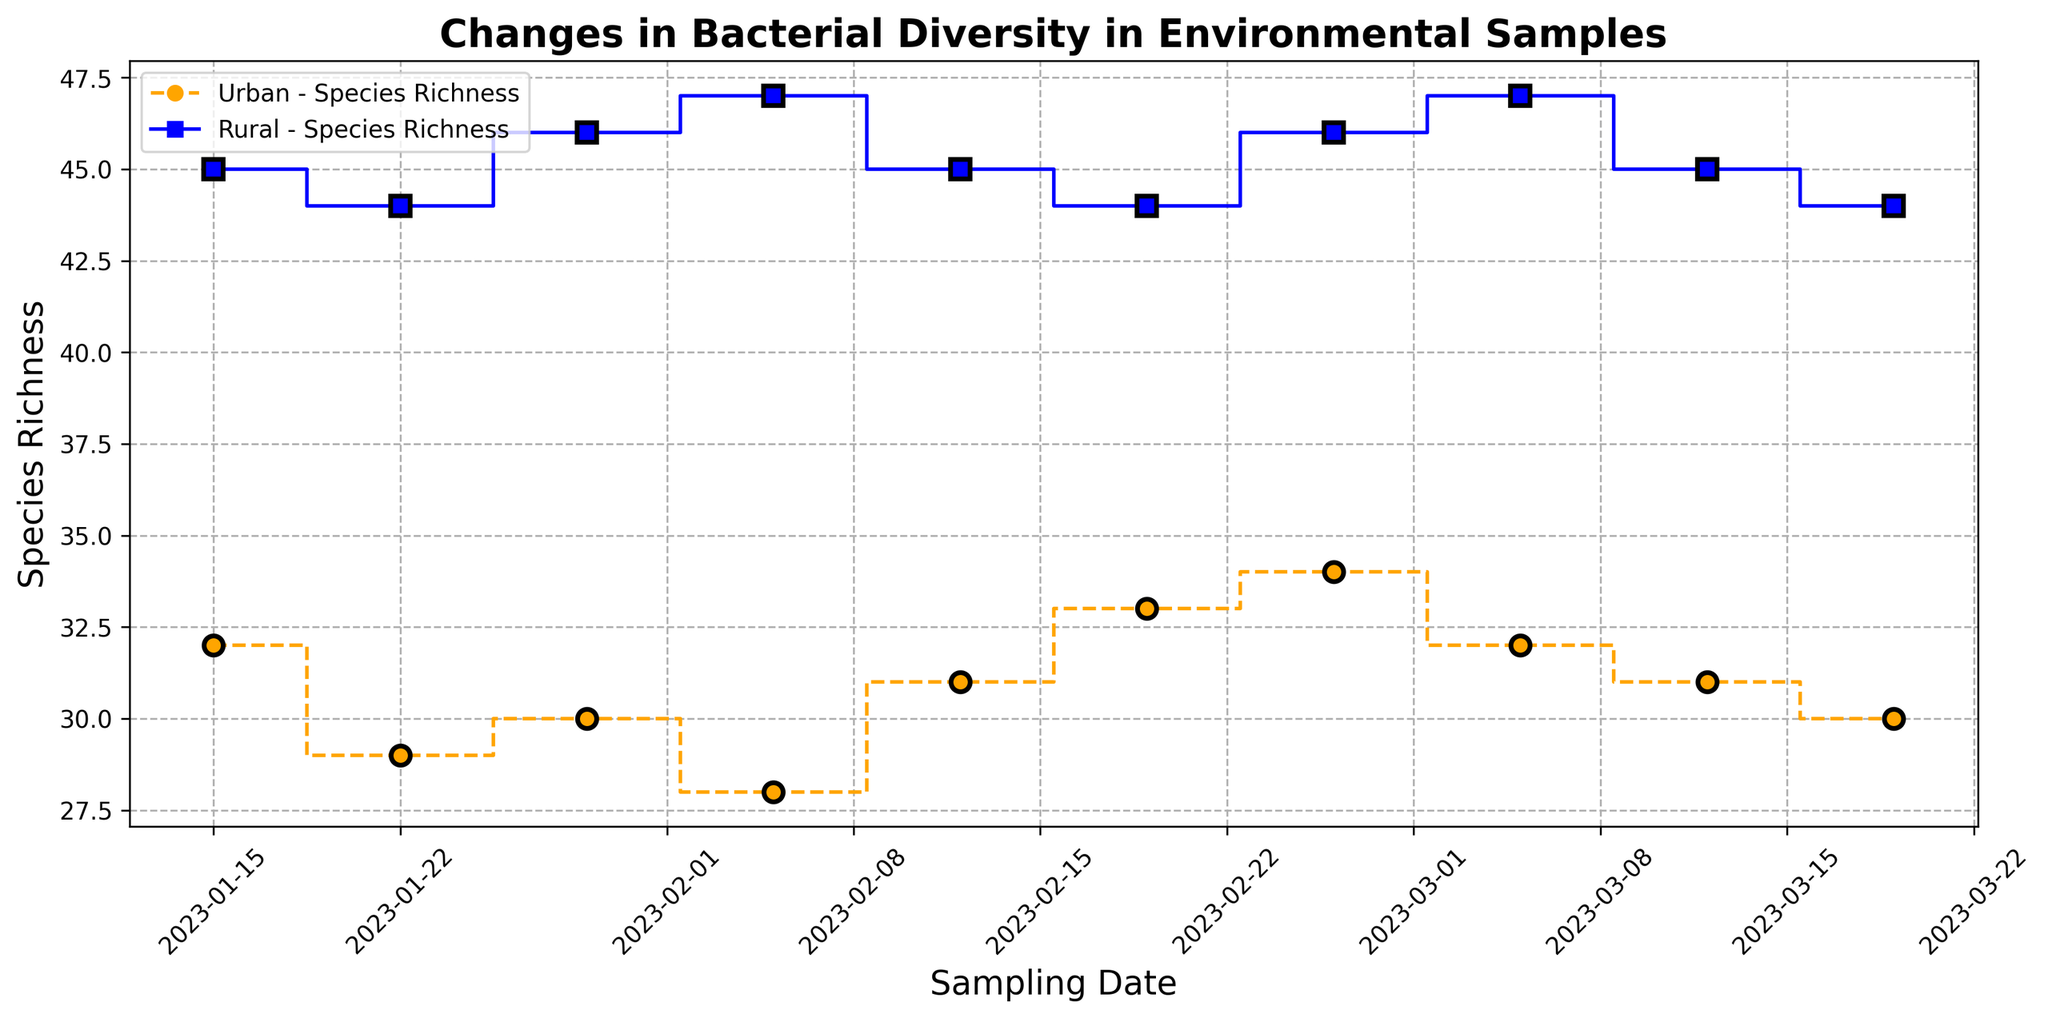What is the overall trend in Species Richness for Urban samples from January to March? The step plot for urban samples shows a moderate fluctuation in species richness from January to March, oscillating around 28 to 34. Starting with a value of 32 in mid-January, it drops slightly to around 28 by early February. Then it peaks again at 34 in late February before stabilizing at around 30-32 in March.
Answer: Moderate fluctuations with an oscillation around 28-34 What is the difference in Species Richness between the Urban sample on January 15 and March 19? The Urban sample on January 15 has a species richness of 32, while the value on March 19 is 30. The difference is calculated as 32 - 30.
Answer: 2 Which location type generally has higher Species Richness, Urban or Rural? Observing the plot, the Rural samples consistently show higher species richness values, ranging from 44 to 47, compared to the Urban samples, which range from 28 to 34.
Answer: Rural Between February 5 and March 5, did the Urban species richness ever exceed that of the Rural samples? To answer this, compare each timeframe between February 5 and March 5 for both Urban and Rural locations. The Urban samples range from 28 to 32, while the Rural samples remain between 44 and 47 during the same period. The Urban species richness never exceeds the Rural samples.
Answer: No How does the visual style differentiate between Urban and Rural samples on the plot? The Urban samples are represented with orange dashed lines and circular markers, while the Rural samples are shown with blue solid lines and square markers.
Answer: Color and marker style If you average the species richness values across all sampling dates for Urban samples, what do you get? Sum the species richness values for Urban samples over all dates: 32+29+30+28+31+33+34+32+31+30. This equals 310. There are 10 dates, so the average is calculated as 310/10.
Answer: 31 Comparing the species richness trends, do the Rural samples exhibit more or less variability compared to Urban samples? The Rural samples display relatively stable species richness values ranging from 44 to 47, indicating less variability. In contrast, Urban samples fluctuate between 28 and 34, showing more variability.
Answer: Less variability What happens to the Rural species richness between January 15 and March 19? The Rural species richness shows minor fluctuations and remains relatively stable, starting at 45 on January 15 and concluding at 44 on March 19, with values oscillating mildly between 44 and 47 throughout the period.
Answer: Minor fluctuations, relatively stable Is there any overlap in species richness values for Urban and Rural samples throughout the sampling period? The Urban samples have species richness values ranging between 28 and 34, while the Rural samples range between 44 and 47. There is no overlap in species richness values between the two locations during the entire sampling period.
Answer: No 